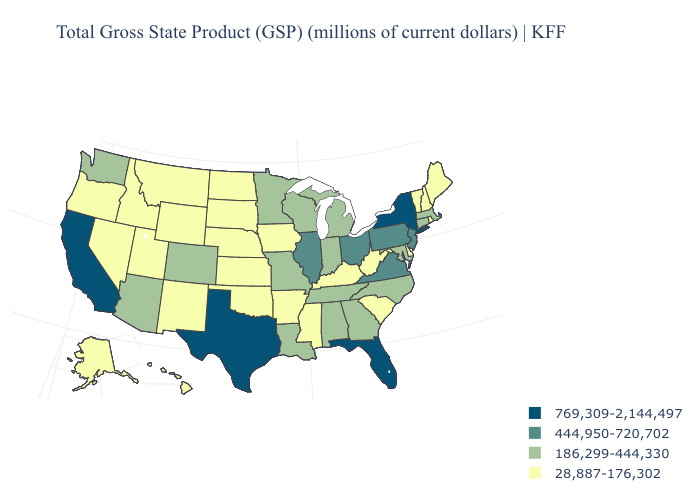What is the value of California?
Quick response, please. 769,309-2,144,497. What is the value of Louisiana?
Answer briefly. 186,299-444,330. Among the states that border Michigan , does Ohio have the lowest value?
Concise answer only. No. Which states have the lowest value in the MidWest?
Keep it brief. Iowa, Kansas, Nebraska, North Dakota, South Dakota. Which states have the lowest value in the USA?
Answer briefly. Alaska, Arkansas, Delaware, Hawaii, Idaho, Iowa, Kansas, Kentucky, Maine, Mississippi, Montana, Nebraska, Nevada, New Hampshire, New Mexico, North Dakota, Oklahoma, Oregon, Rhode Island, South Carolina, South Dakota, Utah, Vermont, West Virginia, Wyoming. Name the states that have a value in the range 186,299-444,330?
Short answer required. Alabama, Arizona, Colorado, Connecticut, Georgia, Indiana, Louisiana, Maryland, Massachusetts, Michigan, Minnesota, Missouri, North Carolina, Tennessee, Washington, Wisconsin. Does Michigan have the same value as Nebraska?
Answer briefly. No. What is the lowest value in states that border Alabama?
Give a very brief answer. 28,887-176,302. Name the states that have a value in the range 186,299-444,330?
Concise answer only. Alabama, Arizona, Colorado, Connecticut, Georgia, Indiana, Louisiana, Maryland, Massachusetts, Michigan, Minnesota, Missouri, North Carolina, Tennessee, Washington, Wisconsin. What is the value of Oklahoma?
Keep it brief. 28,887-176,302. Name the states that have a value in the range 186,299-444,330?
Write a very short answer. Alabama, Arizona, Colorado, Connecticut, Georgia, Indiana, Louisiana, Maryland, Massachusetts, Michigan, Minnesota, Missouri, North Carolina, Tennessee, Washington, Wisconsin. What is the value of Tennessee?
Be succinct. 186,299-444,330. What is the lowest value in states that border New Mexico?
Concise answer only. 28,887-176,302. Among the states that border Iowa , which have the lowest value?
Be succinct. Nebraska, South Dakota. Name the states that have a value in the range 444,950-720,702?
Give a very brief answer. Illinois, New Jersey, Ohio, Pennsylvania, Virginia. 